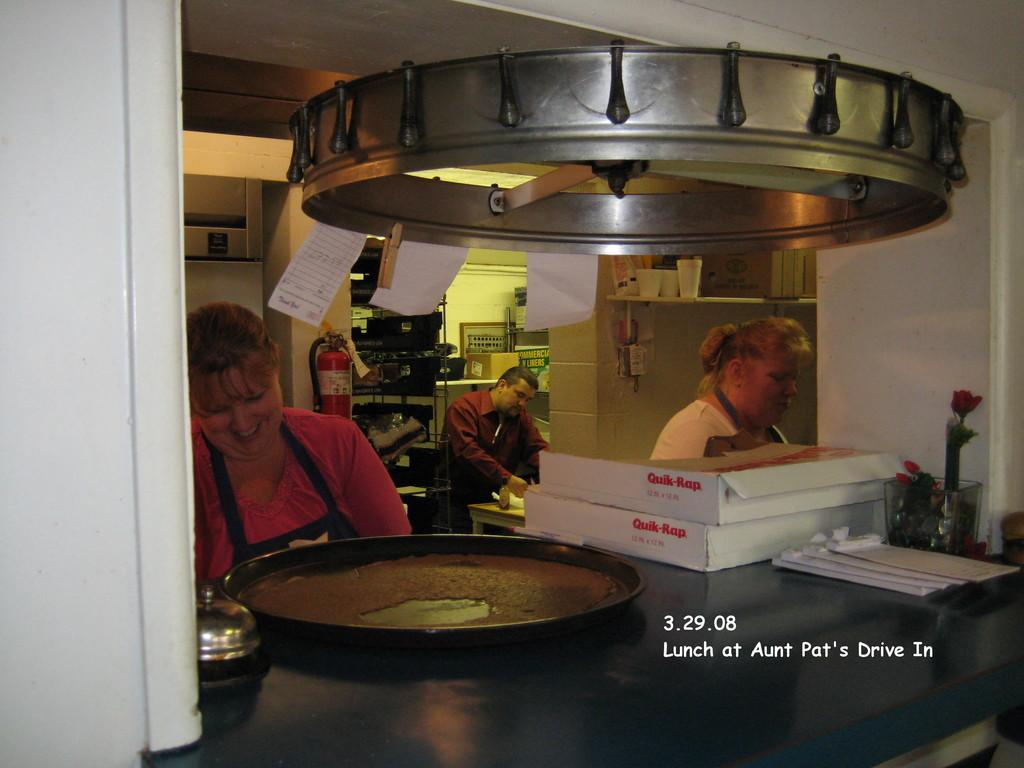<image>
Share a concise interpretation of the image provided. People are making food at Aunt Pat's Drive In. 